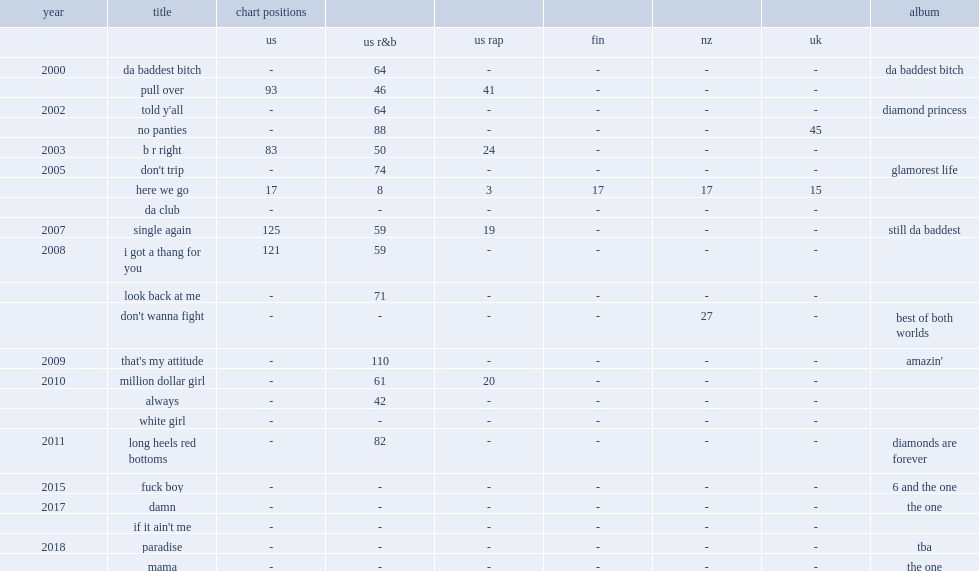Which single did trina make her debut in 2000 with? Da baddest bitch. 